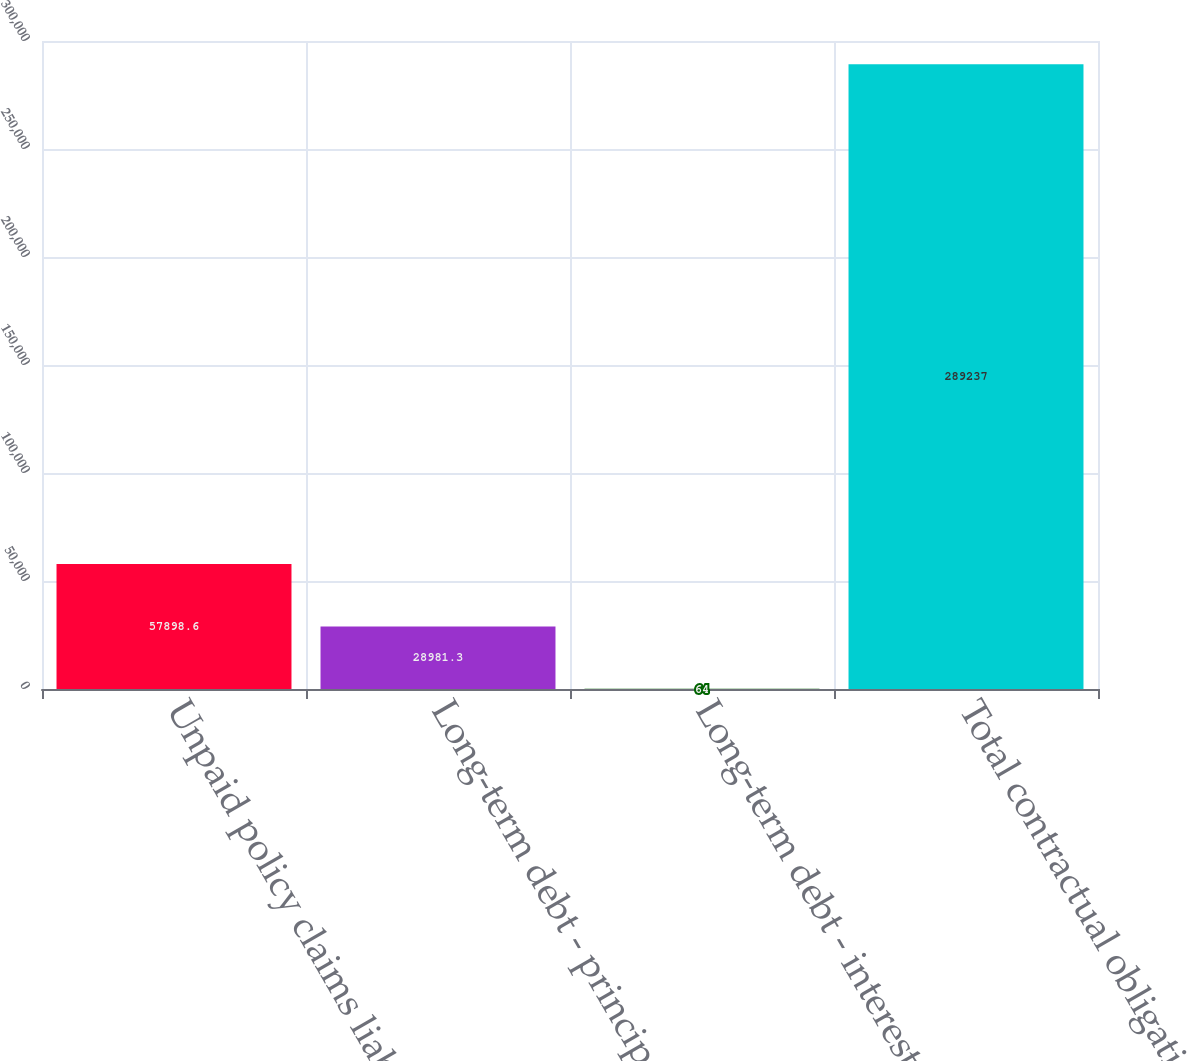<chart> <loc_0><loc_0><loc_500><loc_500><bar_chart><fcel>Unpaid policy claims liability<fcel>Long-term debt - principal<fcel>Long-term debt - interest<fcel>Total contractual obligations<nl><fcel>57898.6<fcel>28981.3<fcel>64<fcel>289237<nl></chart> 